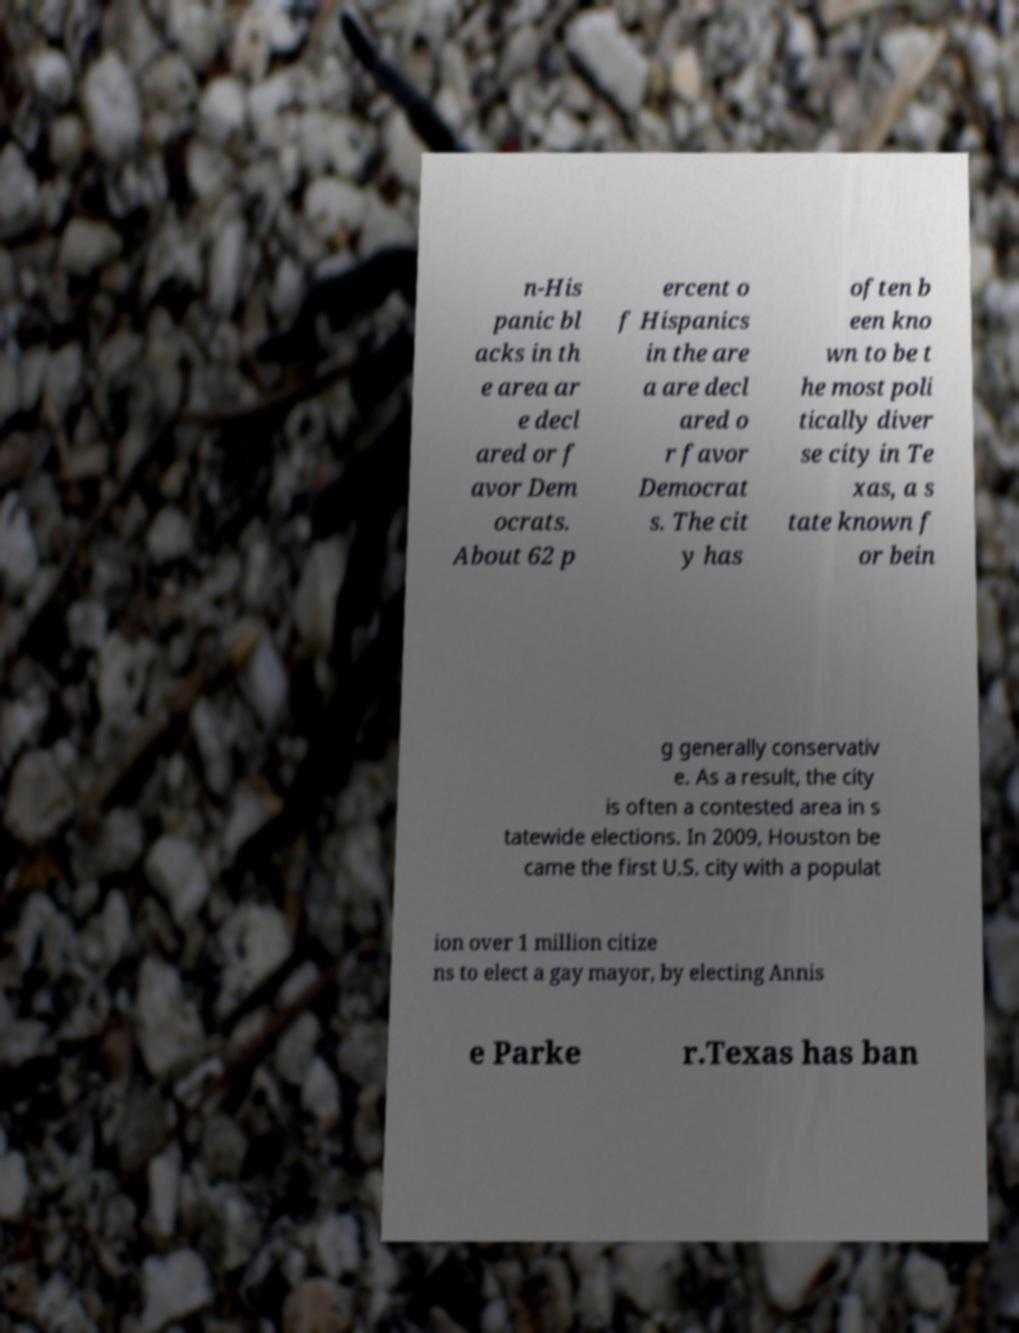Could you extract and type out the text from this image? n-His panic bl acks in th e area ar e decl ared or f avor Dem ocrats. About 62 p ercent o f Hispanics in the are a are decl ared o r favor Democrat s. The cit y has often b een kno wn to be t he most poli tically diver se city in Te xas, a s tate known f or bein g generally conservativ e. As a result, the city is often a contested area in s tatewide elections. In 2009, Houston be came the first U.S. city with a populat ion over 1 million citize ns to elect a gay mayor, by electing Annis e Parke r.Texas has ban 